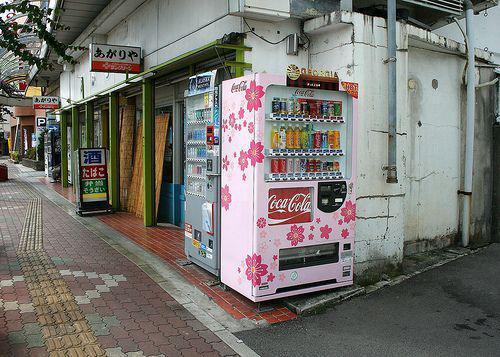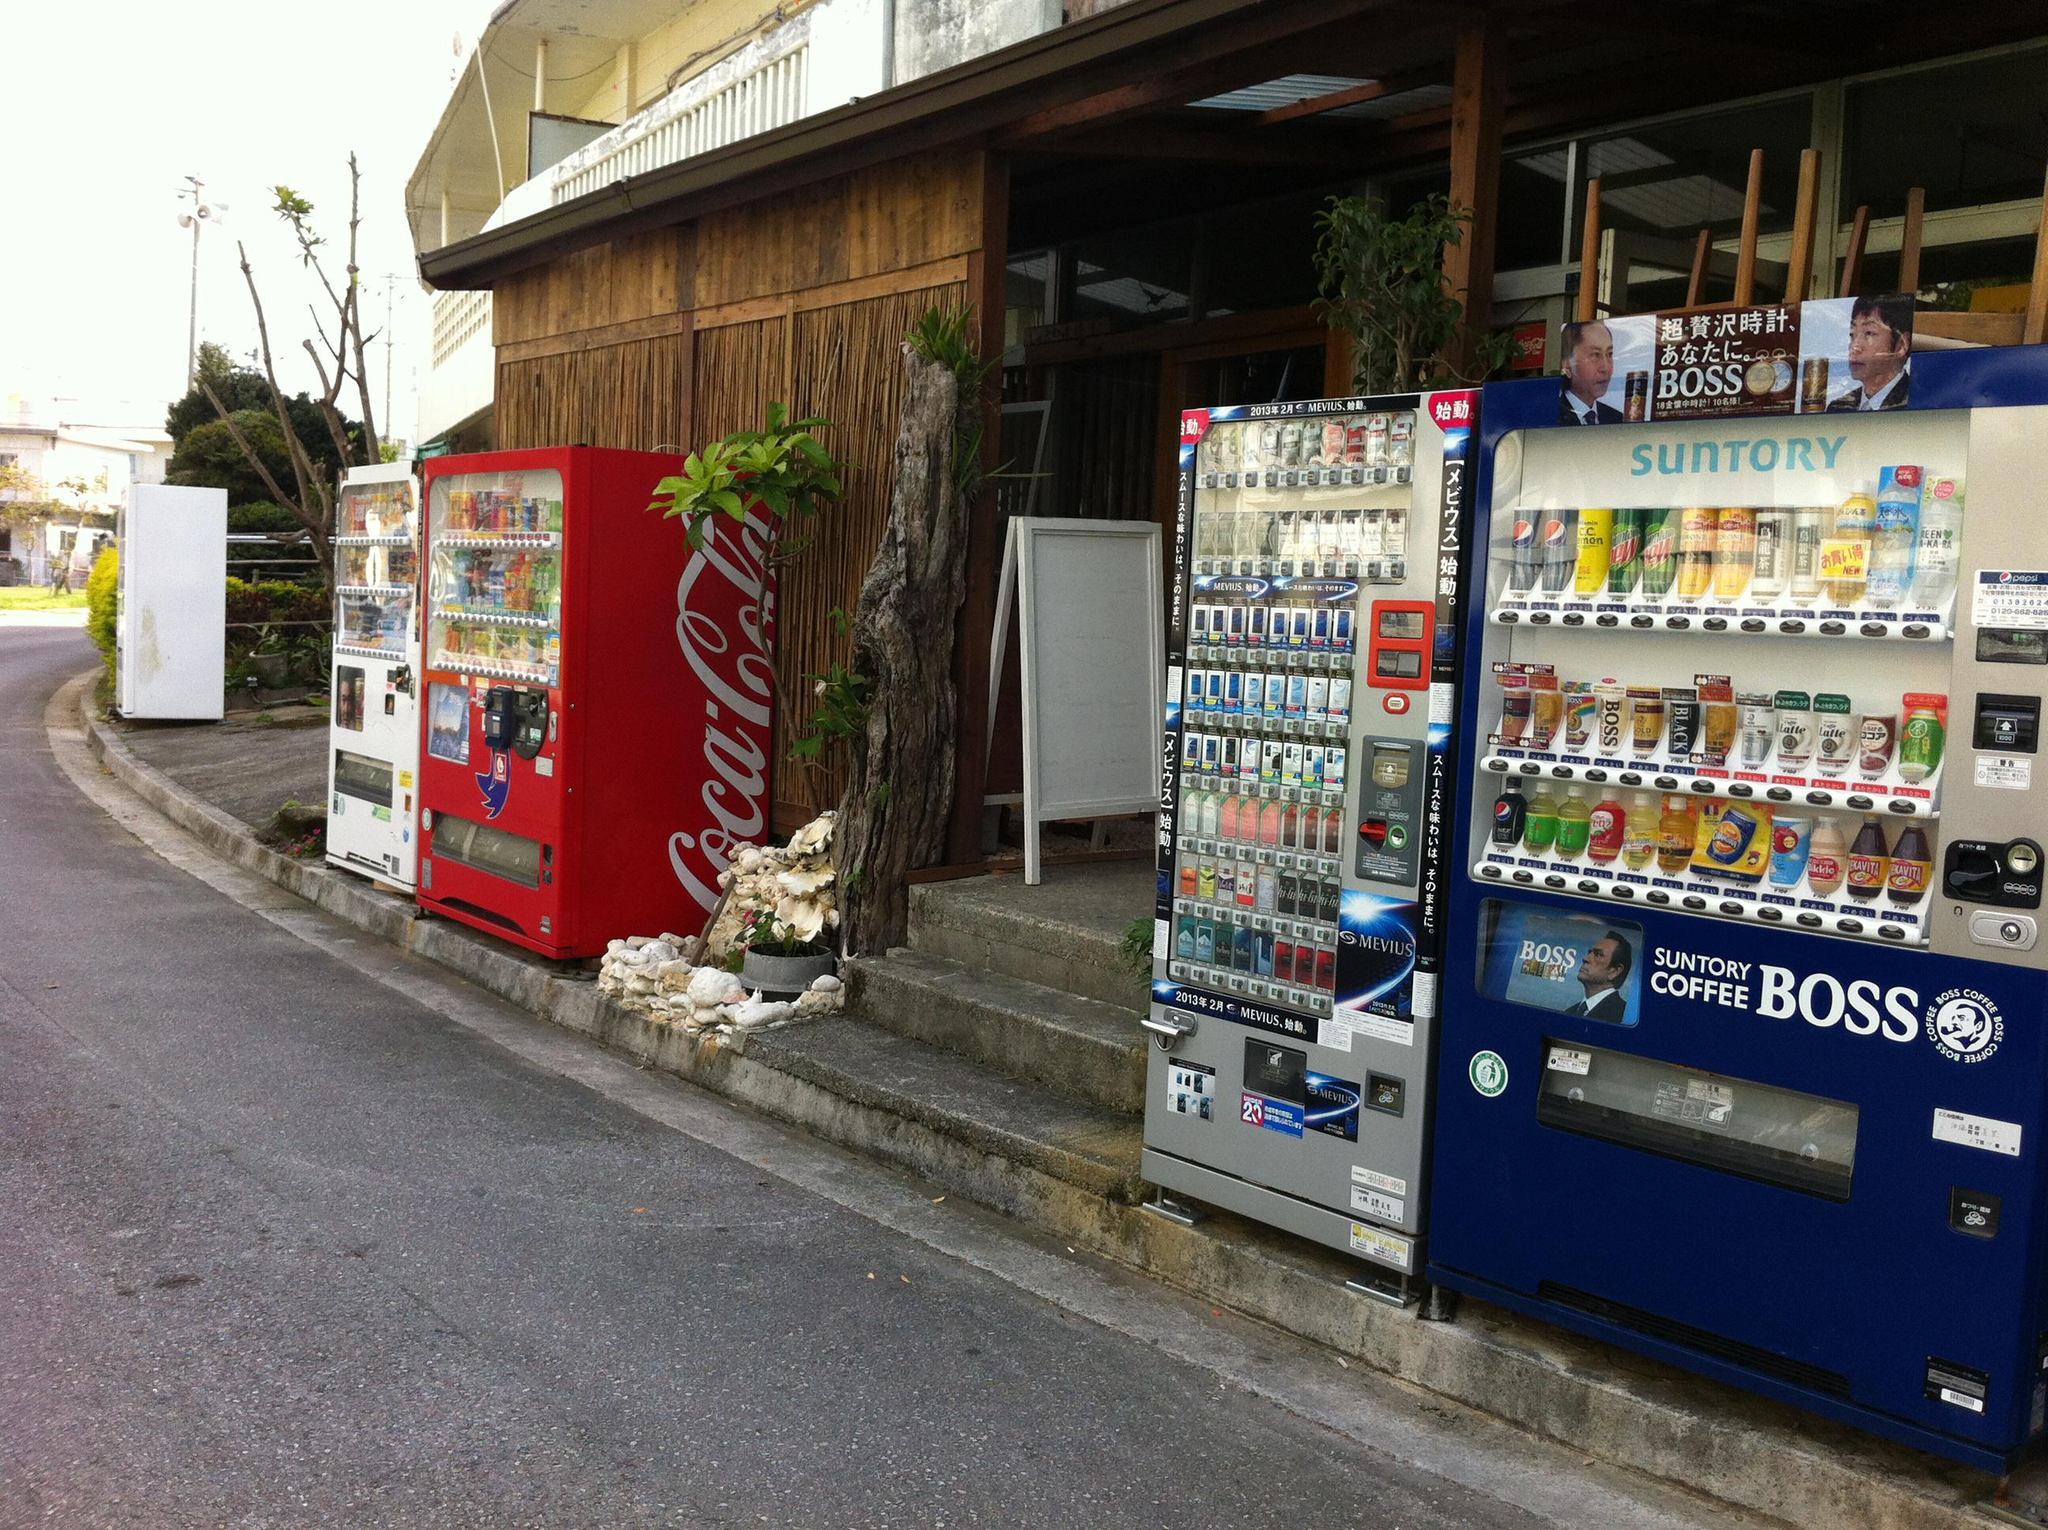The first image is the image on the left, the second image is the image on the right. Given the left and right images, does the statement "One image contains exactly one red vending machine." hold true? Answer yes or no. Yes. 